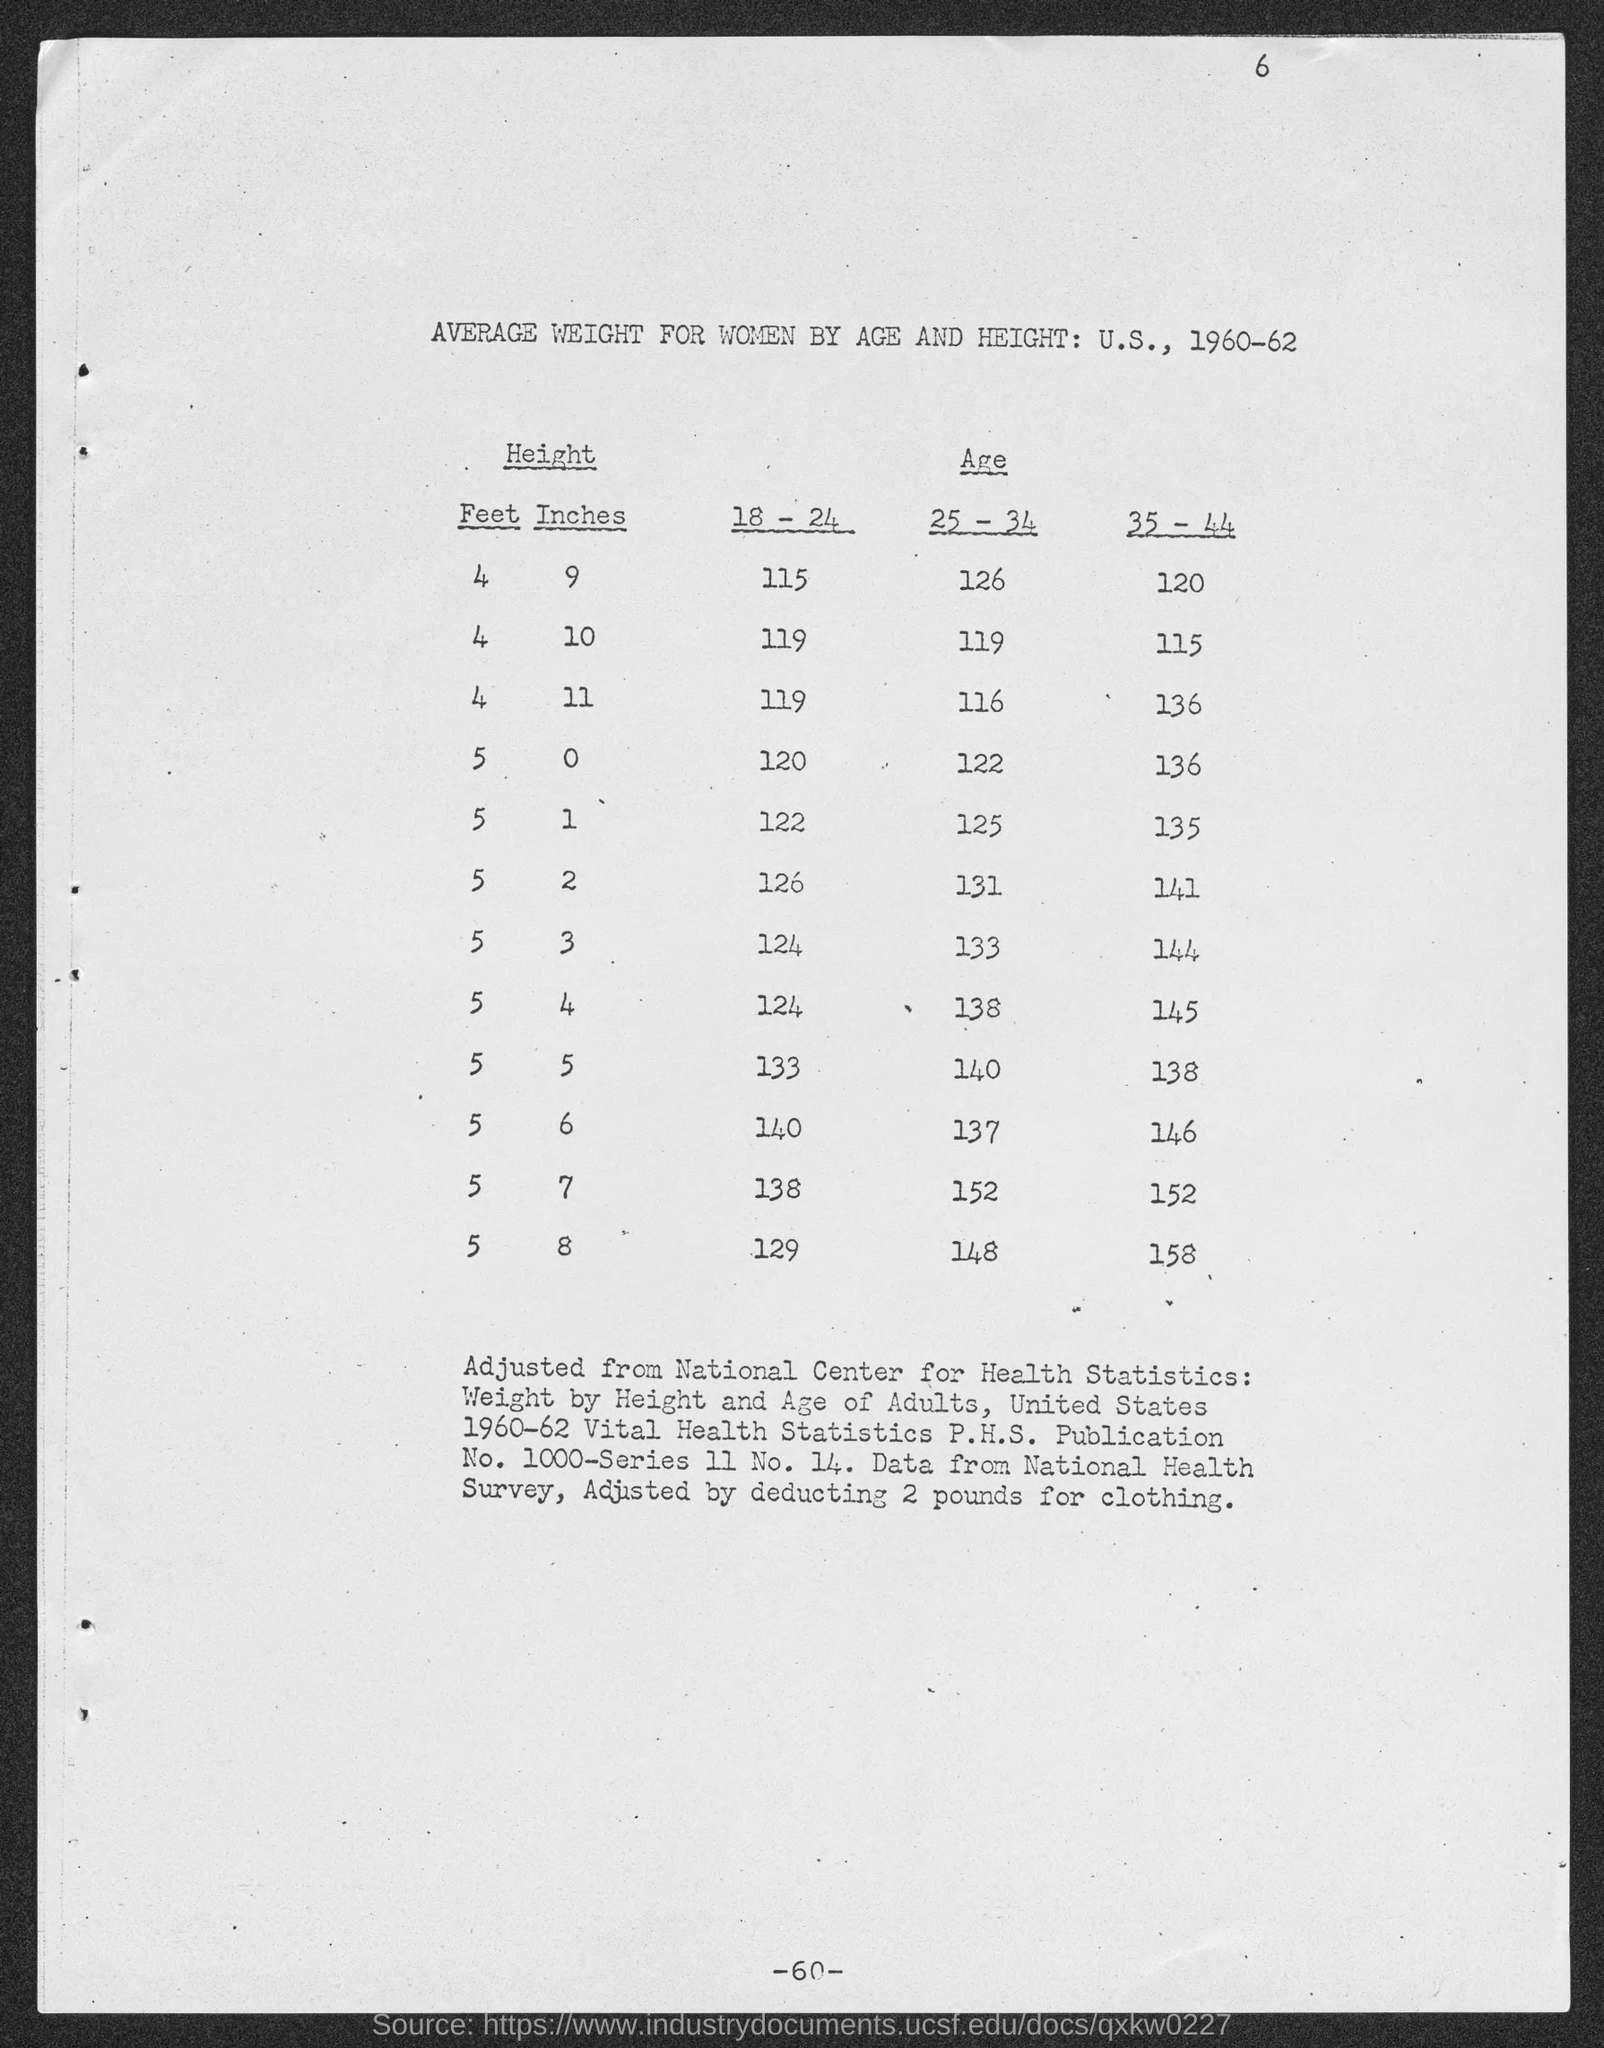Can you tell me more about how the average weights differ between the age groups listed? Certainly! The table categorizes average weights for women across three age groups: 18-24, 25-34, and 35-44. As we move from the 18-24 age group to the 35-44 age group, there is a general trend of increasing average weight. For instance, at a height of 5 feet 5 inches, the weight increases from 133 pounds in the youngest age group to 140 pounds in the middle age group and further to 145 pounds in the oldest age group. This could suggest changes in body composition and lifestyle with increasing age. 